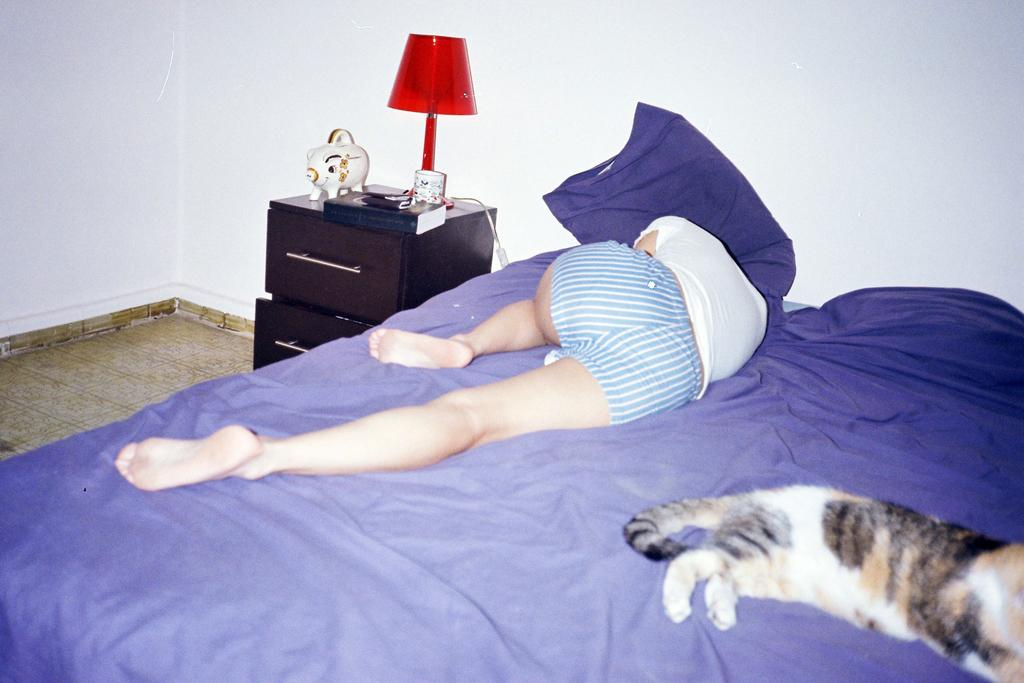Who is present in the image? There is a woman in the image. What is the woman doing in the image? The woman is sleeping on a bed. Is there any other living creature present in the image? Yes, there is a cat beside the woman on the bed. What type of prose can be heard being read aloud in the image? There is no indication in the image that any prose is being read aloud. 